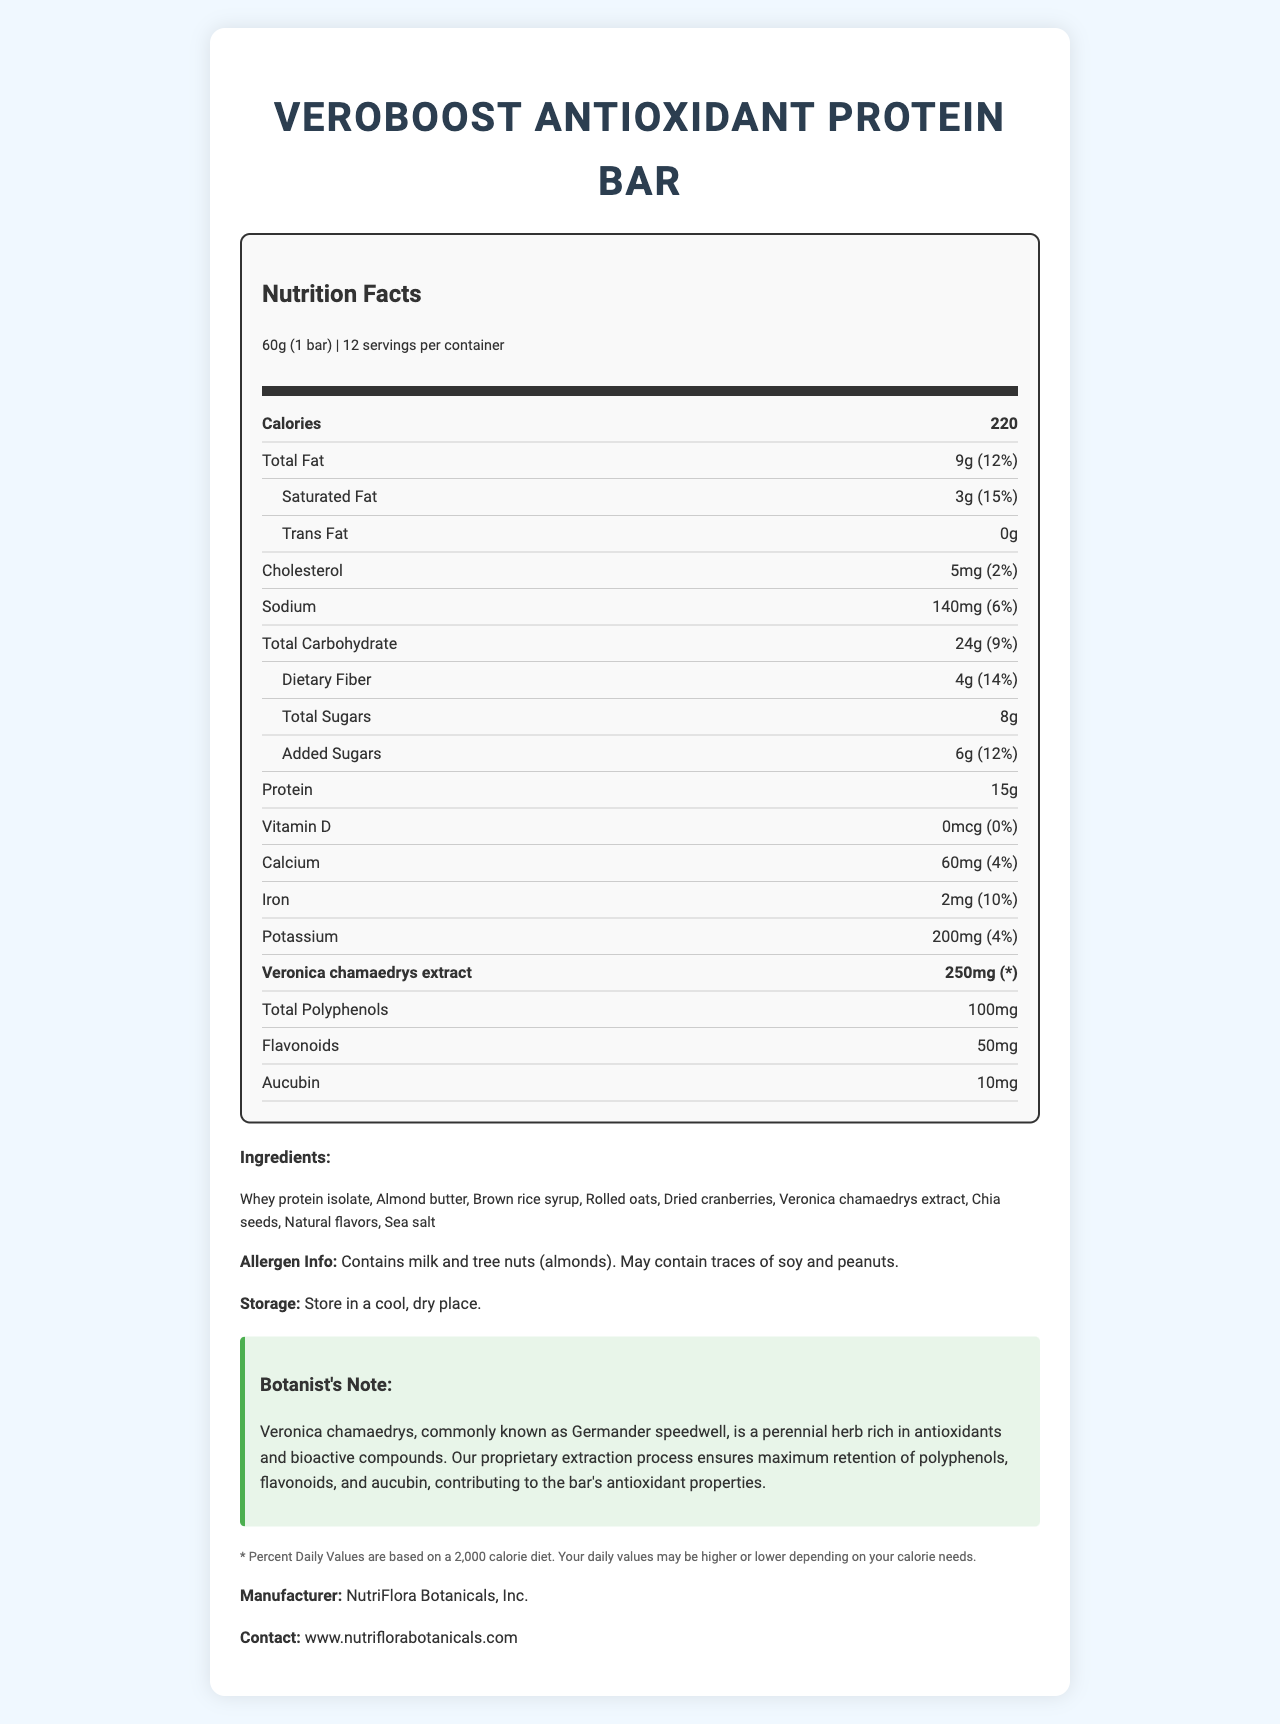what is the serving size for VeroBoost Antioxidant Protein Bar? The serving size is clearly mentioned under the serving information as "60g (1 bar)".
Answer: 60g (1 bar) how many calories are there per serving? The calorie content per serving is displayed as "220" in the nutrition label.
Answer: 220 how much total fat does one bar contain? The total fat content is shown as "9g" under the nutrition section of the label.
Answer: 9g how much protein is in each bar? The protein content for each bar is listed as "15g".
Answer: 15g what is the amount of dietary fiber in one serving? The document mentions that each serving has "4g" of dietary fiber.
Answer: 4g what is the amount of Veronica chamaedrys extract in one serving of the bar? Veronica chamaedrys extract is specifically mentioned as having "250mg" in each serving.
Answer: 250mg how much calcium does the VeroBoost Antioxidant Protein Bar provide per serving? The calcium content is listed under the nutrition information as "60mg".
Answer: 60mg Aucubin, a compound present in Veronica chamaedrys extract, is present in what quantity per serving? The amount of aucubin per serving is listed as "10mg" under the antioxidant content section.
Answer: 10mg which of the following nutrients has the highest daily value percentage: A. Iron B. Dietary Fiber C. Calcium D. Potassium? The daily value percentages listed are: Iron (10%), Dietary Fiber (14%), Calcium (4%), Potassium (4%). Dietary Fiber has the highest daily value percentage at 14%.
Answer: B. Dietary Fiber which allergen is not listed in the VeroBoost Antioxidant Protein Bar: A. Milk B. Tree Nuts (almonds) C. Soy D. Gluten? The allergen information states the bar contains milk and tree nuts (almonds) and may contain traces of soy and peanuts but does not mention gluten.
Answer: D. Gluten is there any added sugar in one bar of VeroBoost? The document lists "added sugars" as "6g", indicating there is added sugar.
Answer: Yes does the VeroBoost Antioxidant Protein Bar contain any trans fat? The trans fat content is listed as "0g", indicating the bar contains no trans fat.
Answer: No summarize the main idea of the VeroBoost Antioxidant Protein Bar nutrition and ingredients information. This summary captures the key elements of the document, including nutritional content, ingredients, and specific highlights related to Veronica chamaedrys extract.
Answer: The VeroBoost Antioxidant Protein Bar is a protein bar enhanced with Veronica chamaedrys extract, which provides significant antioxidant properties. Each 60g bar contains 220 calories, 15g of protein, 9g of total fat, and a range of essential nutrients. The bar is free from trans fats and gluten but contains milk and almonds. It's specifically formulated to benefit from the antioxidants found in Veronica chamaedrys, including polyphenols, flavonoids, and aucubin. who manufactures the VeroBoost Antioxidant Protein Bar? The manufacturer is listed at the end of the document as "NutriFlora Botanicals, Inc."
Answer: NutriFlora Botanicals, Inc. what percentage of daily value is contributed by sodium in one bar? The daily value percentage for sodium is listed as "6%" in the nutrition facts.
Answer: 6% does the bar contain any dietary fiber? The bar contains dietary fiber, as indicated by "4g" in the document.
Answer: Yes, 4g what is the recommended storage condition for the VeroBoost Antioxidant Protein Bar? The recommended storage condition is stated clearly in the text as "Store in a cool, dry place."
Answer: Store in a cool, dry place. what is the website for contacting the manufacturer? The contact website is listed at the end of the document as "www.nutriflorabotanicals.com."
Answer: www.nutriflorabotanicals.com how many servings are there per container? The document lists "servings per container" as 12 under the serving information.
Answer: 12 what is the total polyphenols content per serving? The total content of polyphenols per serving is listed under the antioxidant content as "100mg".
Answer: 100mg can you determine the precise cost of one VeroBoost Antioxidant Protein Bar from the document? There is no information provided in the document about the price or cost of the VeroBoost Antioxidant Protein Bar.
Answer: Not enough information 